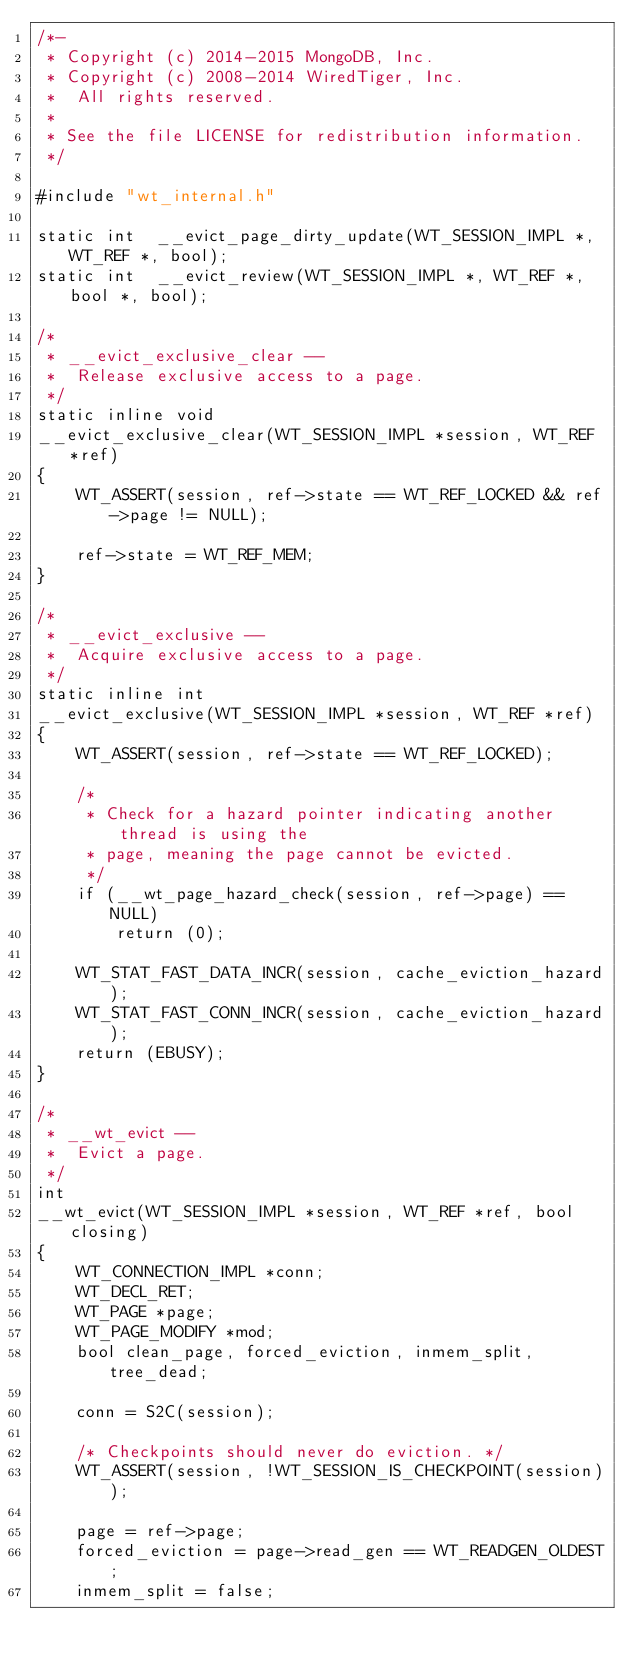<code> <loc_0><loc_0><loc_500><loc_500><_C_>/*-
 * Copyright (c) 2014-2015 MongoDB, Inc.
 * Copyright (c) 2008-2014 WiredTiger, Inc.
 *	All rights reserved.
 *
 * See the file LICENSE for redistribution information.
 */

#include "wt_internal.h"

static int  __evict_page_dirty_update(WT_SESSION_IMPL *, WT_REF *, bool);
static int  __evict_review(WT_SESSION_IMPL *, WT_REF *, bool *, bool);

/*
 * __evict_exclusive_clear --
 *	Release exclusive access to a page.
 */
static inline void
__evict_exclusive_clear(WT_SESSION_IMPL *session, WT_REF *ref)
{
	WT_ASSERT(session, ref->state == WT_REF_LOCKED && ref->page != NULL);

	ref->state = WT_REF_MEM;
}

/*
 * __evict_exclusive --
 *	Acquire exclusive access to a page.
 */
static inline int
__evict_exclusive(WT_SESSION_IMPL *session, WT_REF *ref)
{
	WT_ASSERT(session, ref->state == WT_REF_LOCKED);

	/*
	 * Check for a hazard pointer indicating another thread is using the
	 * page, meaning the page cannot be evicted.
	 */
	if (__wt_page_hazard_check(session, ref->page) == NULL)
		return (0);

	WT_STAT_FAST_DATA_INCR(session, cache_eviction_hazard);
	WT_STAT_FAST_CONN_INCR(session, cache_eviction_hazard);
	return (EBUSY);
}

/*
 * __wt_evict --
 *	Evict a page.
 */
int
__wt_evict(WT_SESSION_IMPL *session, WT_REF *ref, bool closing)
{
	WT_CONNECTION_IMPL *conn;
	WT_DECL_RET;
	WT_PAGE *page;
	WT_PAGE_MODIFY *mod;
	bool clean_page, forced_eviction, inmem_split, tree_dead;

	conn = S2C(session);

	/* Checkpoints should never do eviction. */
	WT_ASSERT(session, !WT_SESSION_IS_CHECKPOINT(session));

	page = ref->page;
	forced_eviction = page->read_gen == WT_READGEN_OLDEST;
	inmem_split = false;</code> 